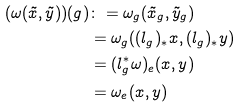<formula> <loc_0><loc_0><loc_500><loc_500>( \omega ( \tilde { x } , \tilde { y } ) ) ( g ) & \colon = \omega _ { g } ( \tilde { x } _ { g } , \tilde { y } _ { g } ) \\ & = \omega _ { g } ( ( l _ { g } ) _ { \ast } x , ( l _ { g } ) _ { \ast } y ) \\ & = ( l _ { g } ^ { \ast } \omega ) _ { e } ( x , y ) \\ & = \omega _ { e } ( x , y )</formula> 